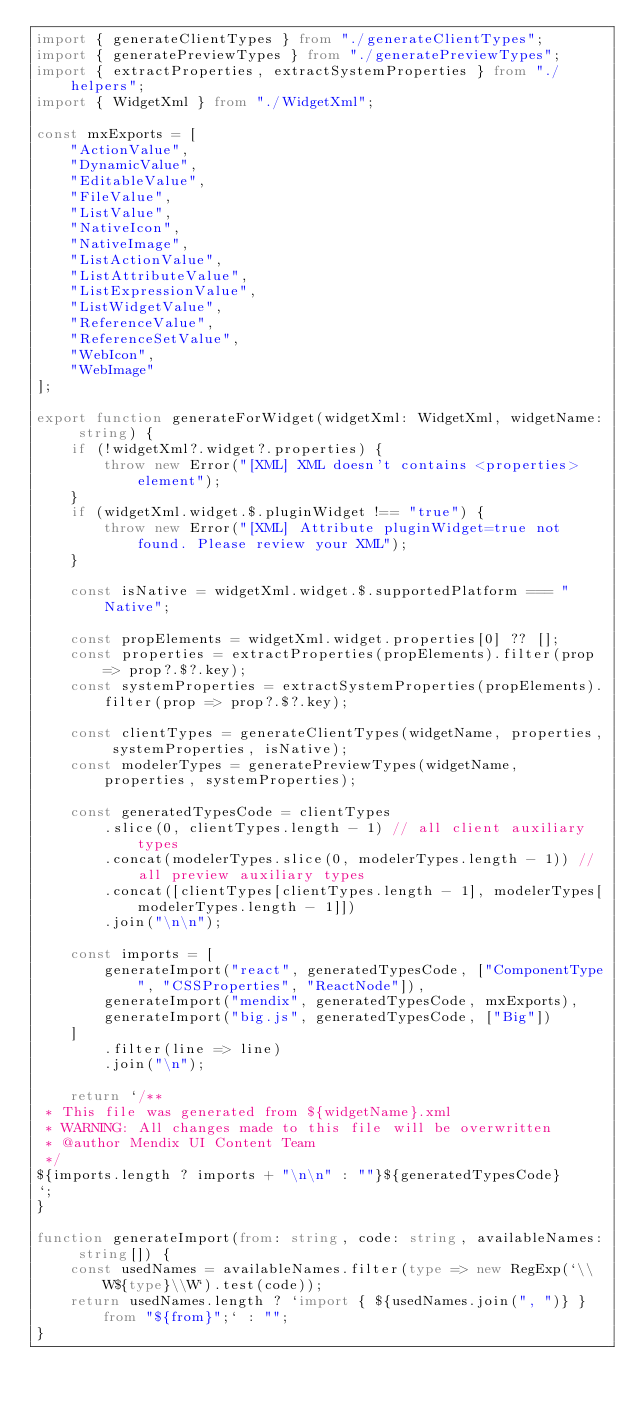<code> <loc_0><loc_0><loc_500><loc_500><_TypeScript_>import { generateClientTypes } from "./generateClientTypes";
import { generatePreviewTypes } from "./generatePreviewTypes";
import { extractProperties, extractSystemProperties } from "./helpers";
import { WidgetXml } from "./WidgetXml";

const mxExports = [
    "ActionValue",
    "DynamicValue",
    "EditableValue",
    "FileValue",
    "ListValue",
    "NativeIcon",
    "NativeImage",
    "ListActionValue",
    "ListAttributeValue",
    "ListExpressionValue",
    "ListWidgetValue",
    "ReferenceValue",
    "ReferenceSetValue",
    "WebIcon",
    "WebImage"
];

export function generateForWidget(widgetXml: WidgetXml, widgetName: string) {
    if (!widgetXml?.widget?.properties) {
        throw new Error("[XML] XML doesn't contains <properties> element");
    }
    if (widgetXml.widget.$.pluginWidget !== "true") {
        throw new Error("[XML] Attribute pluginWidget=true not found. Please review your XML");
    }

    const isNative = widgetXml.widget.$.supportedPlatform === "Native";

    const propElements = widgetXml.widget.properties[0] ?? [];
    const properties = extractProperties(propElements).filter(prop => prop?.$?.key);
    const systemProperties = extractSystemProperties(propElements).filter(prop => prop?.$?.key);

    const clientTypes = generateClientTypes(widgetName, properties, systemProperties, isNative);
    const modelerTypes = generatePreviewTypes(widgetName, properties, systemProperties);

    const generatedTypesCode = clientTypes
        .slice(0, clientTypes.length - 1) // all client auxiliary types
        .concat(modelerTypes.slice(0, modelerTypes.length - 1)) // all preview auxiliary types
        .concat([clientTypes[clientTypes.length - 1], modelerTypes[modelerTypes.length - 1]])
        .join("\n\n");

    const imports = [
        generateImport("react", generatedTypesCode, ["ComponentType", "CSSProperties", "ReactNode"]),
        generateImport("mendix", generatedTypesCode, mxExports),
        generateImport("big.js", generatedTypesCode, ["Big"])
    ]
        .filter(line => line)
        .join("\n");

    return `/**
 * This file was generated from ${widgetName}.xml
 * WARNING: All changes made to this file will be overwritten
 * @author Mendix UI Content Team
 */
${imports.length ? imports + "\n\n" : ""}${generatedTypesCode}
`;
}

function generateImport(from: string, code: string, availableNames: string[]) {
    const usedNames = availableNames.filter(type => new RegExp(`\\W${type}\\W`).test(code));
    return usedNames.length ? `import { ${usedNames.join(", ")} } from "${from}";` : "";
}
</code> 